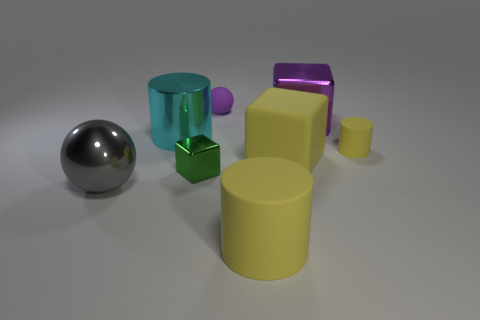Add 2 large brown shiny spheres. How many objects exist? 10 Subtract all cylinders. How many objects are left? 5 Subtract all gray spheres. Subtract all big spheres. How many objects are left? 6 Add 8 small purple matte objects. How many small purple matte objects are left? 9 Add 3 rubber cylinders. How many rubber cylinders exist? 5 Subtract 0 green balls. How many objects are left? 8 